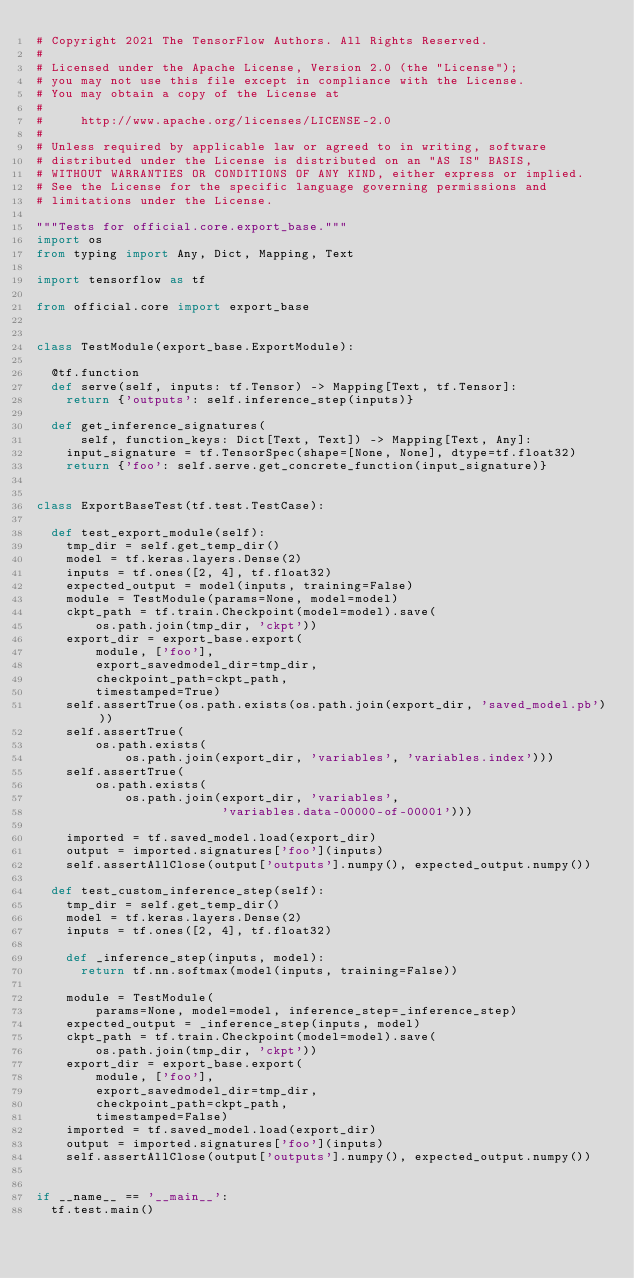<code> <loc_0><loc_0><loc_500><loc_500><_Python_># Copyright 2021 The TensorFlow Authors. All Rights Reserved.
#
# Licensed under the Apache License, Version 2.0 (the "License");
# you may not use this file except in compliance with the License.
# You may obtain a copy of the License at
#
#     http://www.apache.org/licenses/LICENSE-2.0
#
# Unless required by applicable law or agreed to in writing, software
# distributed under the License is distributed on an "AS IS" BASIS,
# WITHOUT WARRANTIES OR CONDITIONS OF ANY KIND, either express or implied.
# See the License for the specific language governing permissions and
# limitations under the License.

"""Tests for official.core.export_base."""
import os
from typing import Any, Dict, Mapping, Text

import tensorflow as tf

from official.core import export_base


class TestModule(export_base.ExportModule):

  @tf.function
  def serve(self, inputs: tf.Tensor) -> Mapping[Text, tf.Tensor]:
    return {'outputs': self.inference_step(inputs)}

  def get_inference_signatures(
      self, function_keys: Dict[Text, Text]) -> Mapping[Text, Any]:
    input_signature = tf.TensorSpec(shape=[None, None], dtype=tf.float32)
    return {'foo': self.serve.get_concrete_function(input_signature)}


class ExportBaseTest(tf.test.TestCase):

  def test_export_module(self):
    tmp_dir = self.get_temp_dir()
    model = tf.keras.layers.Dense(2)
    inputs = tf.ones([2, 4], tf.float32)
    expected_output = model(inputs, training=False)
    module = TestModule(params=None, model=model)
    ckpt_path = tf.train.Checkpoint(model=model).save(
        os.path.join(tmp_dir, 'ckpt'))
    export_dir = export_base.export(
        module, ['foo'],
        export_savedmodel_dir=tmp_dir,
        checkpoint_path=ckpt_path,
        timestamped=True)
    self.assertTrue(os.path.exists(os.path.join(export_dir, 'saved_model.pb')))
    self.assertTrue(
        os.path.exists(
            os.path.join(export_dir, 'variables', 'variables.index')))
    self.assertTrue(
        os.path.exists(
            os.path.join(export_dir, 'variables',
                         'variables.data-00000-of-00001')))

    imported = tf.saved_model.load(export_dir)
    output = imported.signatures['foo'](inputs)
    self.assertAllClose(output['outputs'].numpy(), expected_output.numpy())

  def test_custom_inference_step(self):
    tmp_dir = self.get_temp_dir()
    model = tf.keras.layers.Dense(2)
    inputs = tf.ones([2, 4], tf.float32)

    def _inference_step(inputs, model):
      return tf.nn.softmax(model(inputs, training=False))

    module = TestModule(
        params=None, model=model, inference_step=_inference_step)
    expected_output = _inference_step(inputs, model)
    ckpt_path = tf.train.Checkpoint(model=model).save(
        os.path.join(tmp_dir, 'ckpt'))
    export_dir = export_base.export(
        module, ['foo'],
        export_savedmodel_dir=tmp_dir,
        checkpoint_path=ckpt_path,
        timestamped=False)
    imported = tf.saved_model.load(export_dir)
    output = imported.signatures['foo'](inputs)
    self.assertAllClose(output['outputs'].numpy(), expected_output.numpy())


if __name__ == '__main__':
  tf.test.main()
</code> 